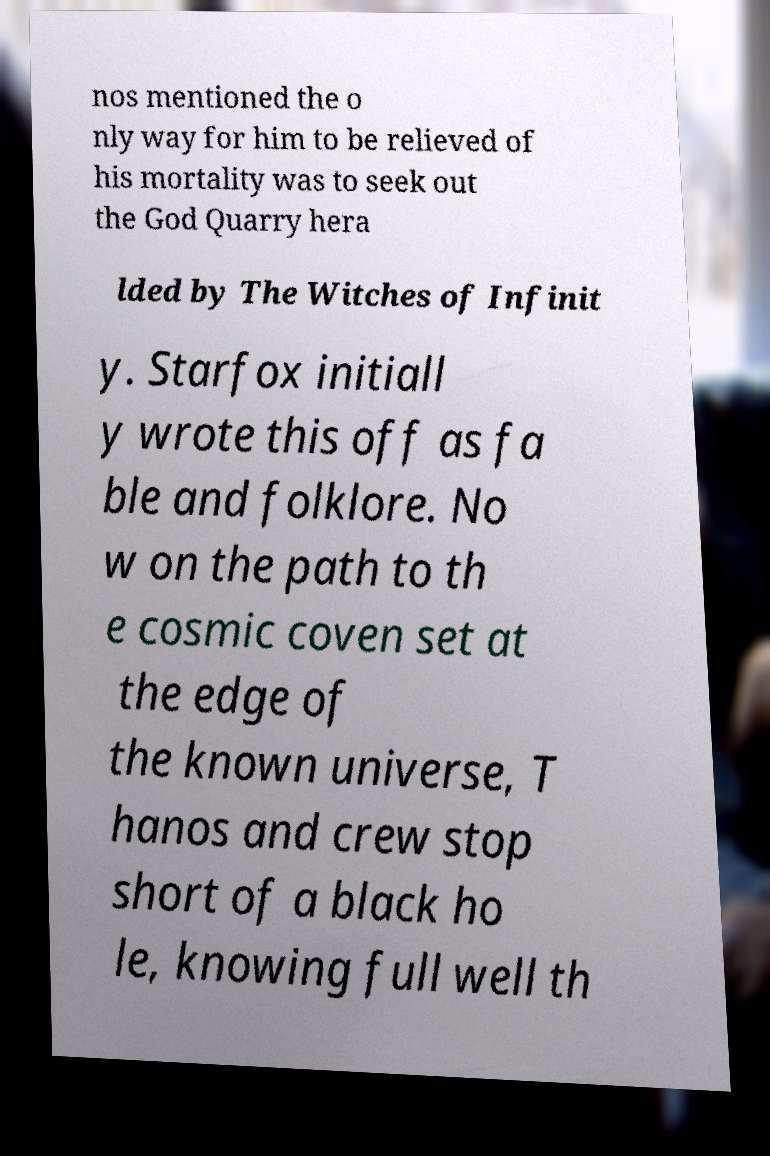What messages or text are displayed in this image? I need them in a readable, typed format. nos mentioned the o nly way for him to be relieved of his mortality was to seek out the God Quarry hera lded by The Witches of Infinit y. Starfox initiall y wrote this off as fa ble and folklore. No w on the path to th e cosmic coven set at the edge of the known universe, T hanos and crew stop short of a black ho le, knowing full well th 